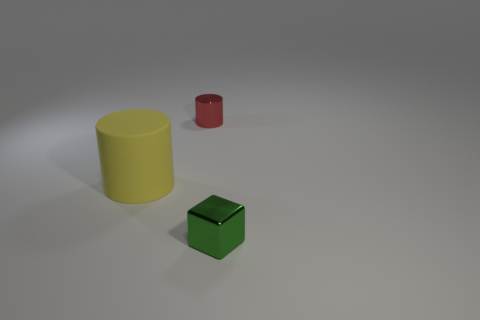Could these objects be part of a children's toy set? Absolutely, the brightly colored geometric shapes – a yellow cylinder, a red smaller cylinder, and a green cube – resemble the components of a children's playset designed for learning shapes and colors. Their simplistic design and primary colors are characteristic of educational toys aimed at engaging young children in shape recognition and sorting activities. 